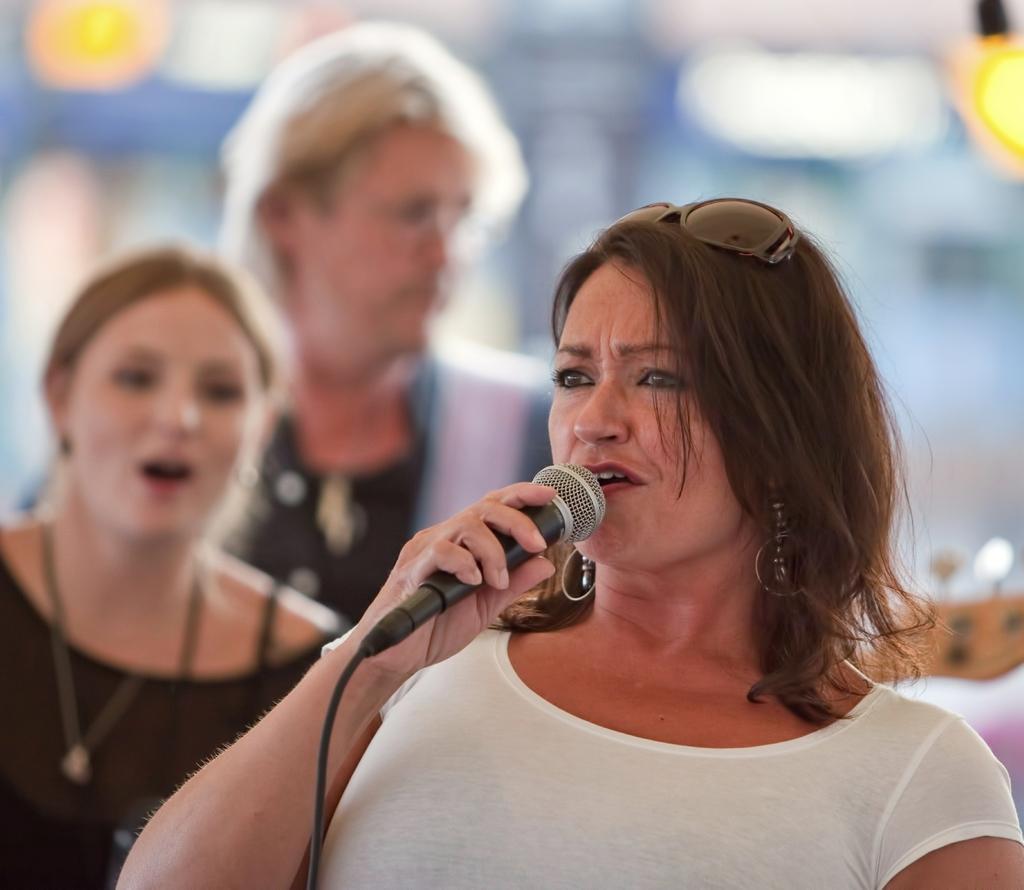In one or two sentences, can you explain what this image depicts? In this picture we can see woman holding mic in her hand and talking and at back of her we can see two other woman and in background we can see lights and it is blurry. 